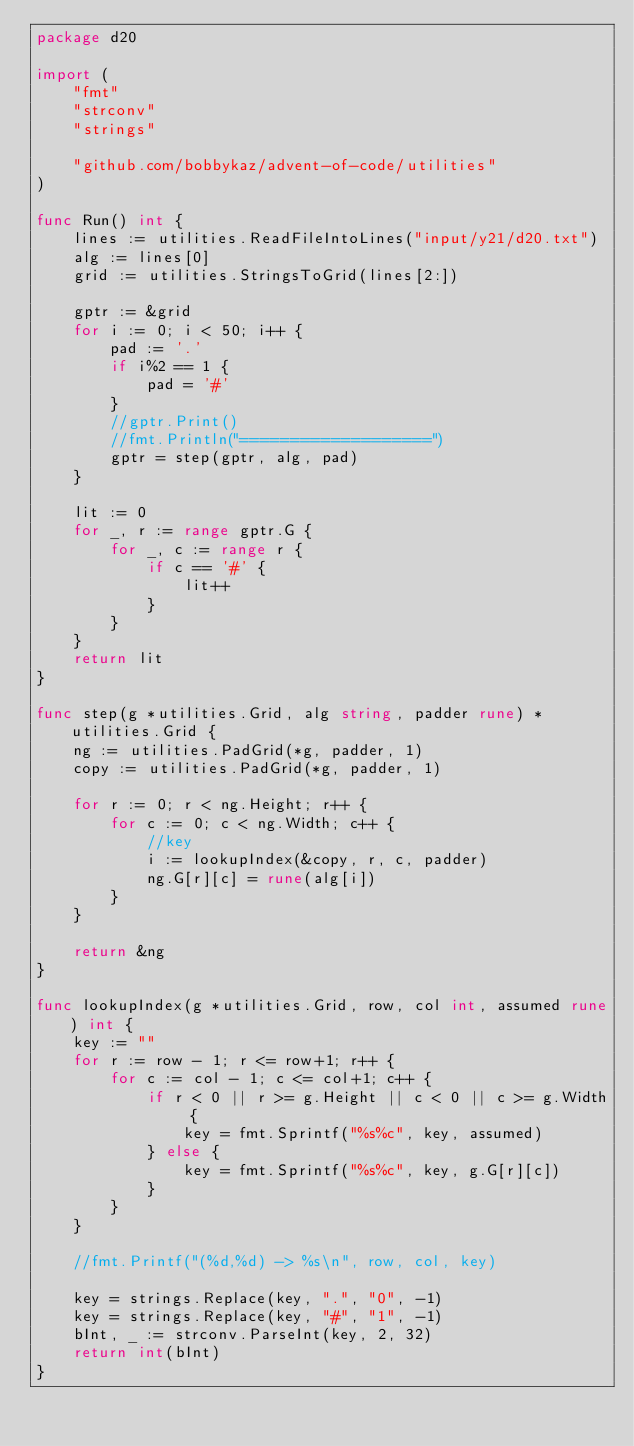<code> <loc_0><loc_0><loc_500><loc_500><_Go_>package d20

import (
	"fmt"
	"strconv"
	"strings"

	"github.com/bobbykaz/advent-of-code/utilities"
)

func Run() int {
	lines := utilities.ReadFileIntoLines("input/y21/d20.txt")
	alg := lines[0]
	grid := utilities.StringsToGrid(lines[2:])

	gptr := &grid
	for i := 0; i < 50; i++ {
		pad := '.'
		if i%2 == 1 {
			pad = '#'
		}
		//gptr.Print()
		//fmt.Println("===================")
		gptr = step(gptr, alg, pad)
	}

	lit := 0
	for _, r := range gptr.G {
		for _, c := range r {
			if c == '#' {
				lit++
			}
		}
	}
	return lit
}

func step(g *utilities.Grid, alg string, padder rune) *utilities.Grid {
	ng := utilities.PadGrid(*g, padder, 1)
	copy := utilities.PadGrid(*g, padder, 1)

	for r := 0; r < ng.Height; r++ {
		for c := 0; c < ng.Width; c++ {
			//key
			i := lookupIndex(&copy, r, c, padder)
			ng.G[r][c] = rune(alg[i])
		}
	}

	return &ng
}

func lookupIndex(g *utilities.Grid, row, col int, assumed rune) int {
	key := ""
	for r := row - 1; r <= row+1; r++ {
		for c := col - 1; c <= col+1; c++ {
			if r < 0 || r >= g.Height || c < 0 || c >= g.Width {
				key = fmt.Sprintf("%s%c", key, assumed)
			} else {
				key = fmt.Sprintf("%s%c", key, g.G[r][c])
			}
		}
	}

	//fmt.Printf("(%d,%d) -> %s\n", row, col, key)

	key = strings.Replace(key, ".", "0", -1)
	key = strings.Replace(key, "#", "1", -1)
	bInt, _ := strconv.ParseInt(key, 2, 32)
	return int(bInt)
}
</code> 